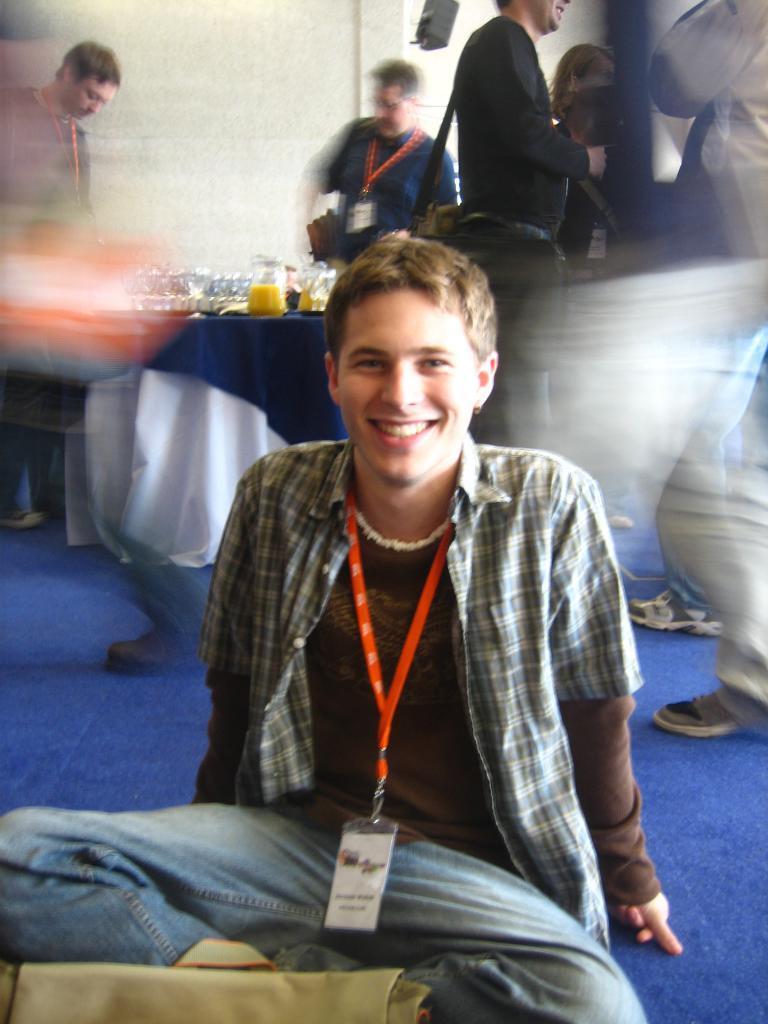Can you describe this image briefly? In this picture there is a boy in the center of the image, who is sitting on the floor and there are other people and a table in the background area of the image. 